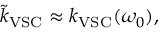<formula> <loc_0><loc_0><loc_500><loc_500>\tilde { k } _ { V S C } \approx k _ { V S C } ( \omega _ { 0 } ) ,</formula> 